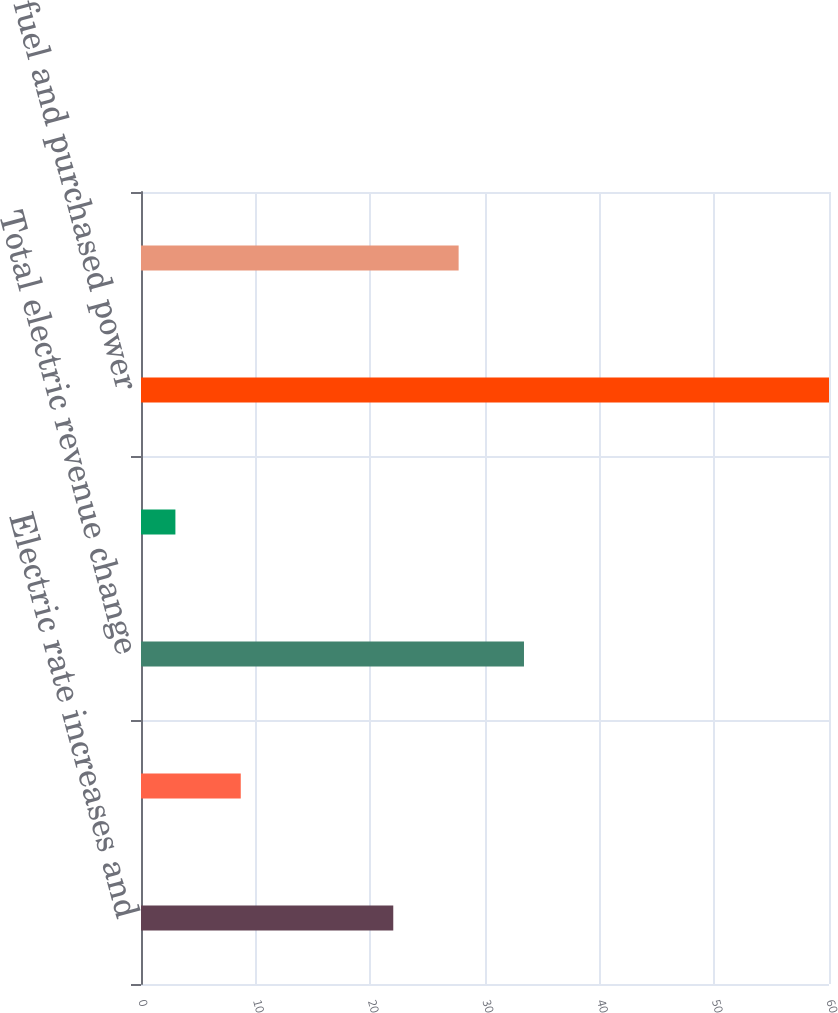<chart> <loc_0><loc_0><loc_500><loc_500><bar_chart><fcel>Electric rate increases and<fcel>Generation output and other<fcel>Total electric revenue change<fcel>Purchased power<fcel>Total fuel and purchased power<fcel>Net change in electric margins<nl><fcel>22<fcel>8.7<fcel>33.4<fcel>3<fcel>60<fcel>27.7<nl></chart> 